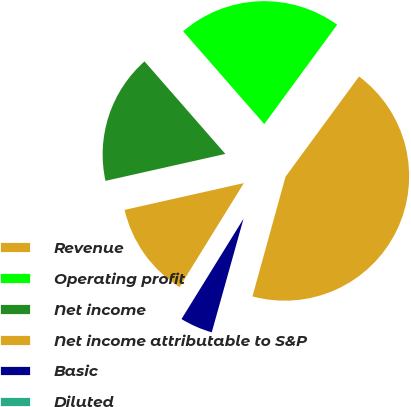Convert chart to OTSL. <chart><loc_0><loc_0><loc_500><loc_500><pie_chart><fcel>Revenue<fcel>Operating profit<fcel>Net income<fcel>Net income attributable to S&P<fcel>Basic<fcel>Diluted<nl><fcel>44.22%<fcel>21.5%<fcel>17.09%<fcel>12.67%<fcel>4.47%<fcel>0.05%<nl></chart> 